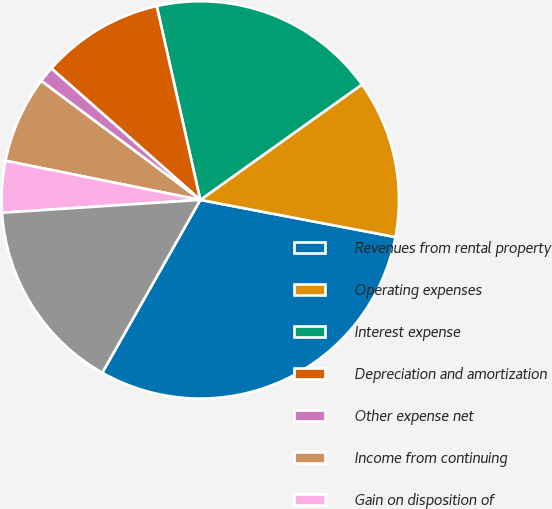<chart> <loc_0><loc_0><loc_500><loc_500><pie_chart><fcel>Revenues from rental property<fcel>Operating expenses<fcel>Interest expense<fcel>Depreciation and amortization<fcel>Other expense net<fcel>Income from continuing<fcel>Gain on disposition of<fcel>Net income<nl><fcel>30.22%<fcel>12.86%<fcel>18.65%<fcel>9.97%<fcel>1.29%<fcel>7.07%<fcel>4.18%<fcel>15.76%<nl></chart> 